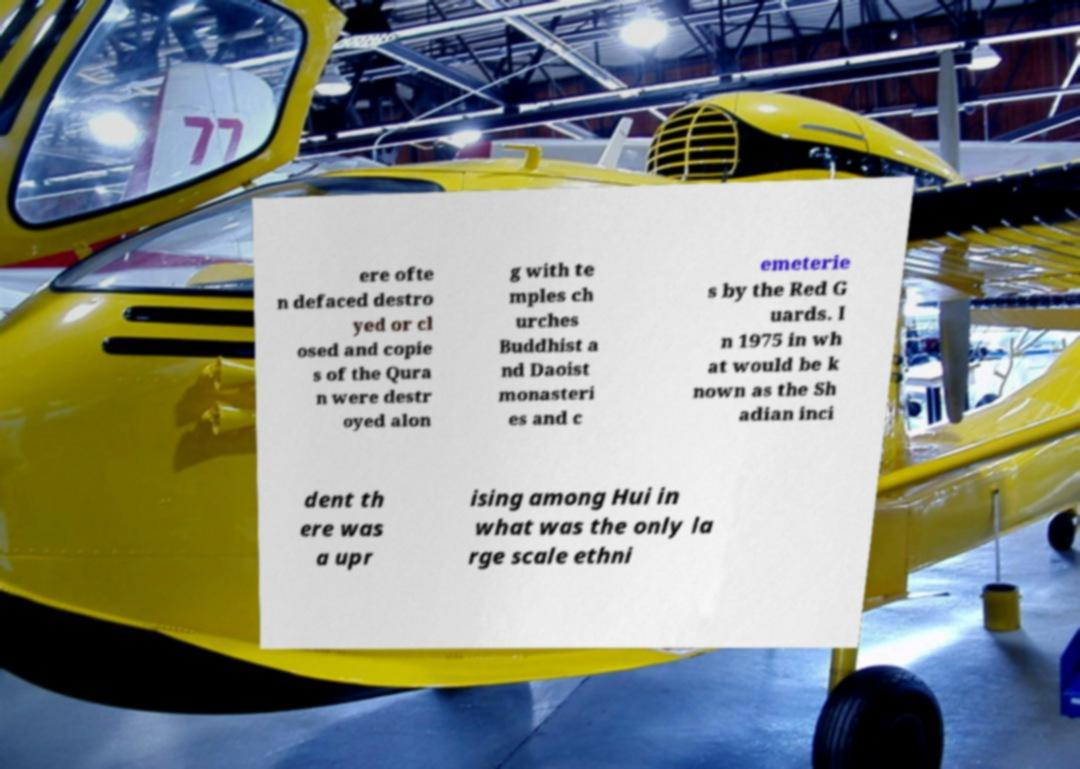Can you accurately transcribe the text from the provided image for me? ere ofte n defaced destro yed or cl osed and copie s of the Qura n were destr oyed alon g with te mples ch urches Buddhist a nd Daoist monasteri es and c emeterie s by the Red G uards. I n 1975 in wh at would be k nown as the Sh adian inci dent th ere was a upr ising among Hui in what was the only la rge scale ethni 